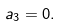<formula> <loc_0><loc_0><loc_500><loc_500>a _ { 3 } = 0 .</formula> 